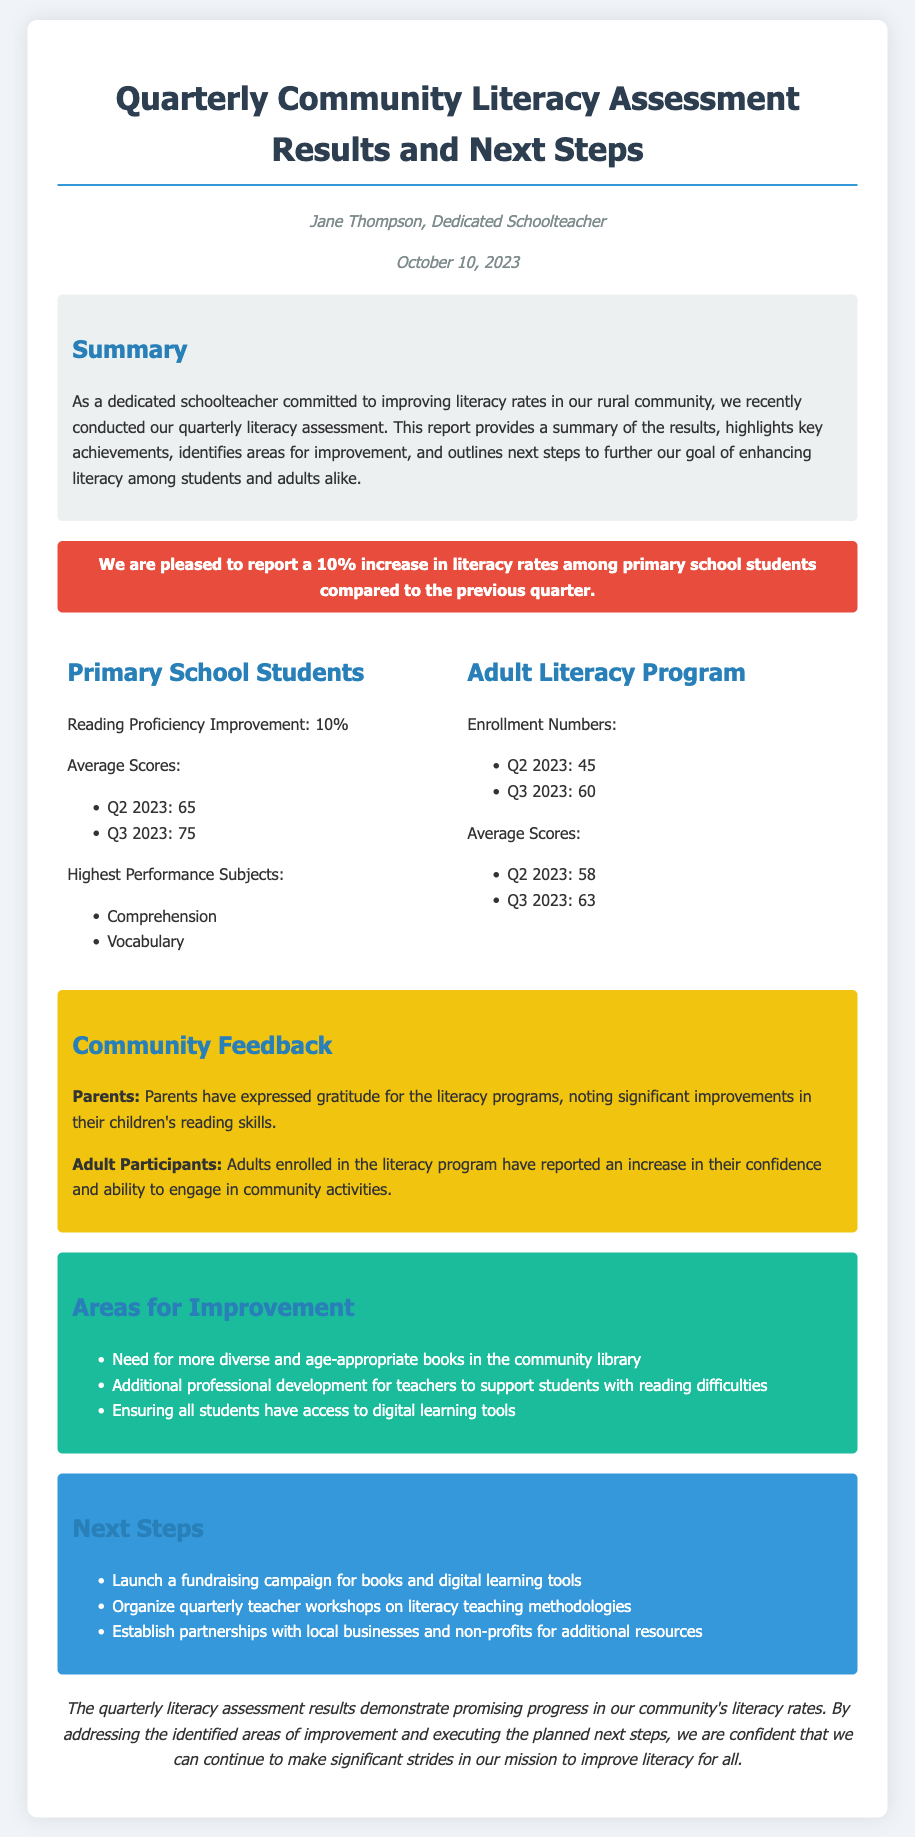what is the name of the author? The author of the document is mentioned as Jane Thompson.
Answer: Jane Thompson what was the increase in literacy rates among primary school students? The document states there was a 10% increase in literacy rates among primary school students.
Answer: 10% what were the average scores for Q2 2023 for primary school students? The average scores for Q2 2023 in primary school students is listed as 65.
Answer: 65 how many adults were enrolled in the literacy program in Q3 2023? The document indicates the enrollment number for Q3 2023 was 60 adults.
Answer: 60 which subjects had the highest performance in primary school students? The subjects identified as the highest performance are comprehensions and vocabulary.
Answer: Comprehension, Vocabulary what feedback did parents provide regarding the literacy programs? Parents expressed gratitude for the literacy programs and noted improvements in their children's reading skills.
Answer: Gratitude for improvements what area needs improvement according to the document? The document lists the need for more diverse and age-appropriate books in the community library as an area for improvement.
Answer: More diverse and age-appropriate books what is one of the next steps outlined in the document? The next step includes launching a fundraising campaign for books and digital learning tools.
Answer: Launch a fundraising campaign what was the average score for adults in Q3 2023? The average score for adults in the literacy program for Q3 2023 is mentioned as 63.
Answer: 63 